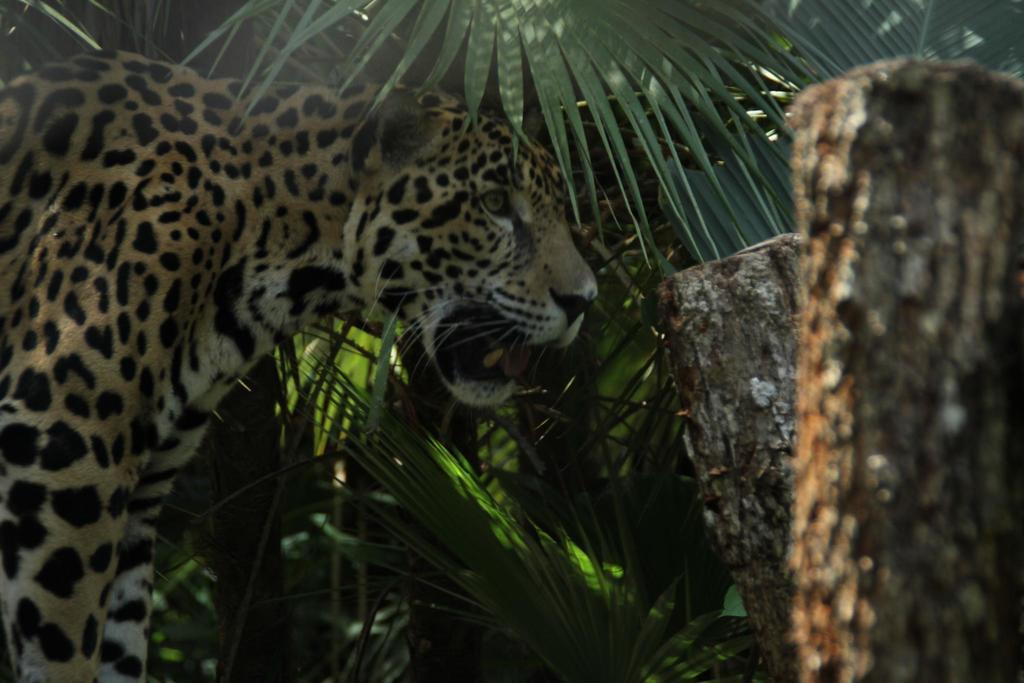Could you give a brief overview of what you see in this image? In this image I can see the tiger which is in black, brown and white color. In-front of the tiger I can see the wooden logs. In the background I can see the plants. 